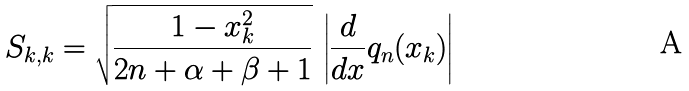Convert formula to latex. <formula><loc_0><loc_0><loc_500><loc_500>S _ { k , k } = \sqrt { \frac { 1 - x _ { k } ^ { 2 } } { 2 n + \alpha + \beta + 1 } } \, \left | \frac { d } { d x } q _ { n } ( x _ { k } ) \right |</formula> 